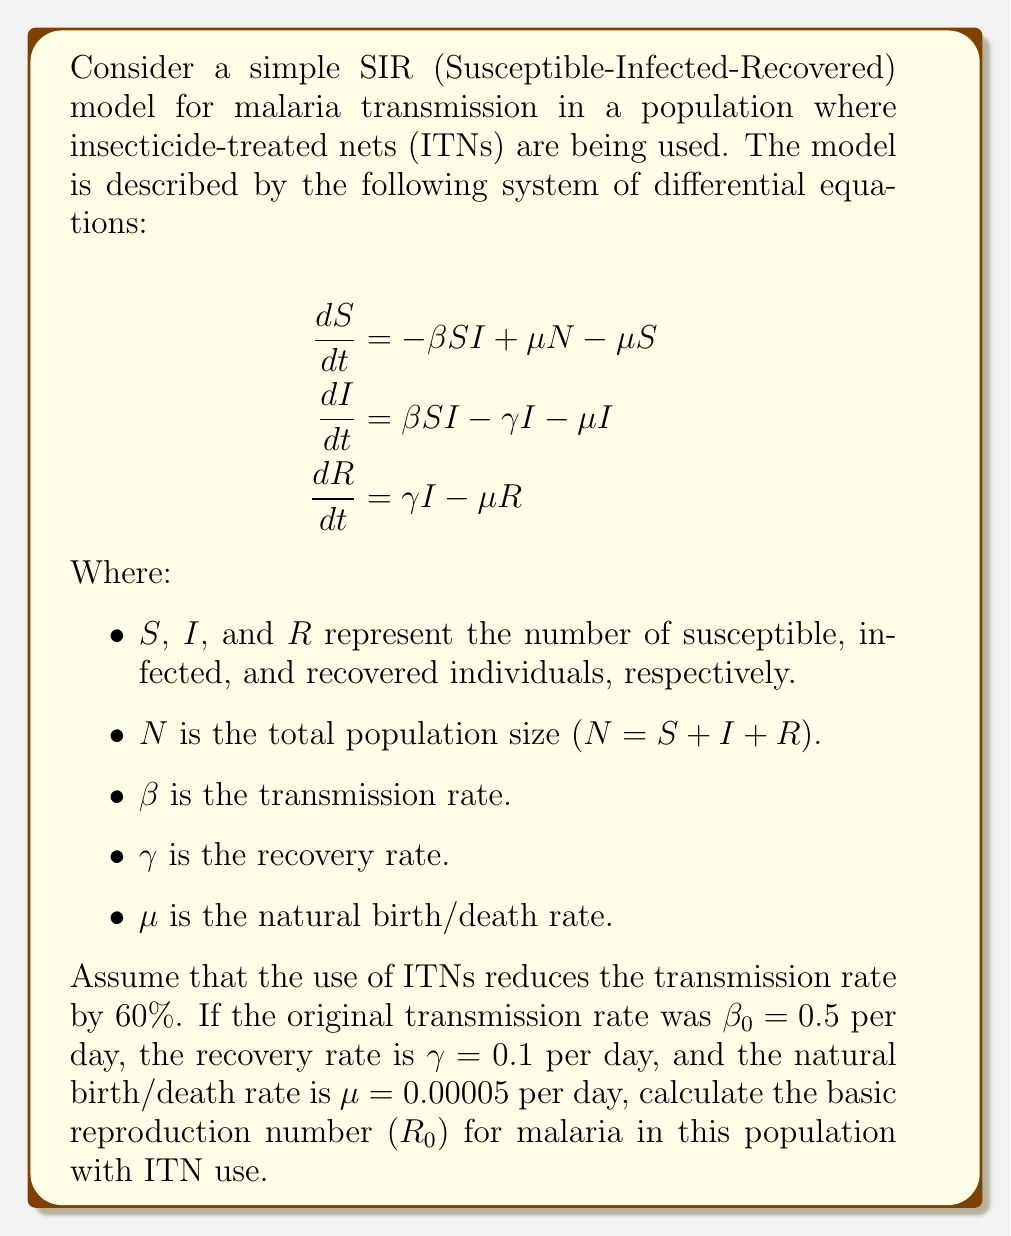Solve this math problem. To solve this problem, we need to follow these steps:

1) First, recall that the basic reproduction number $(R_0)$ for an SIR model is given by:

   $$R_0 = \frac{\beta N}{\gamma + \mu}$$

2) We are told that the use of ITNs reduces the transmission rate by 60%. This means the new transmission rate $\beta$ is 40% of the original rate $\beta_0$:

   $$\beta = 0.4 \beta_0 = 0.4 \times 0.5 = 0.2\text{ per day}$$

3) We are given the following parameters:
   $\beta = 0.2\text{ per day}$
   $\gamma = 0.1\text{ per day}$
   $\mu = 0.00005\text{ per day}$

4) Note that $N$ doesn't appear explicitly in our equation. This is because in the SIR model, $R_0$ represents the average number of secondary infections caused by a single infected individual in a completely susceptible population. Therefore, we can consider $N$ to be large enough that $S \approx N$ at the start of the epidemic.

5) Now we can substitute these values into the $R_0$ formula:

   $$R_0 = \frac{0.2}{0.1 + 0.00005} \approx \frac{0.2}{0.10005}$$

6) Calculate the final result:

   $$R_0 \approx 1.9990$$

This means that, on average, each infected person will infect approximately 2 other people in a fully susceptible population, even with the use of ITNs.
Answer: $R_0 \approx 1.9990$ 